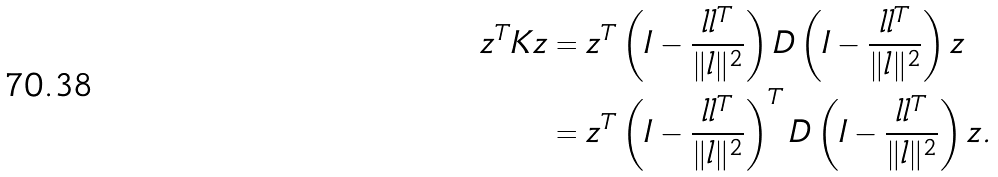<formula> <loc_0><loc_0><loc_500><loc_500>z ^ { T } K z & = z ^ { T } \left ( I - \frac { l l ^ { T } } { \| l \| ^ { 2 } } \right ) D \left ( I - \frac { l l ^ { T } } { \| l \| ^ { 2 } } \right ) z \\ & = z ^ { T } \left ( I - \frac { l l ^ { T } } { \| l \| ^ { 2 } } \right ) ^ { T } D \left ( I - \frac { l l ^ { T } } { \| l \| ^ { 2 } } \right ) z .</formula> 